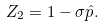Convert formula to latex. <formula><loc_0><loc_0><loc_500><loc_500>Z _ { 2 } = 1 - \sigma \hat { p } .</formula> 